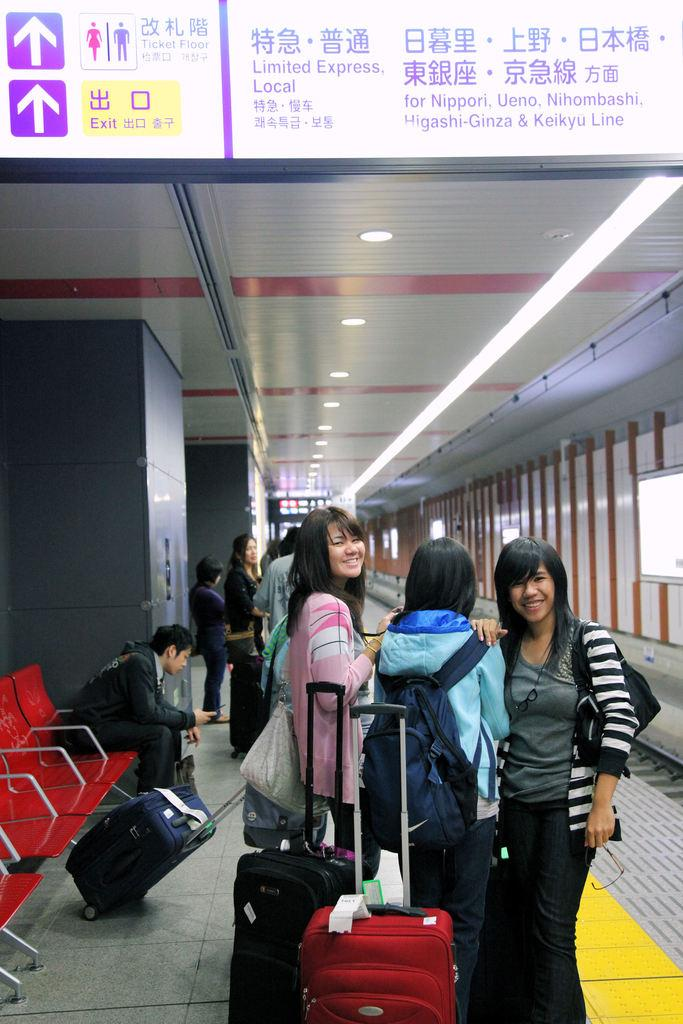What is the main subject of the image? The main subject of the image is a group of people. What are the people in the image doing? The people are standing and holding a suitcase. Can you describe the man in the image? The man is sitting on a chair and holding a mobile. What is visible on the roof in the image? There are lights on the roof. What type of humor can be seen in the image? There is no humor present in the image; it depicts a group of people standing and holding a suitcase, a man sitting on a chair holding a mobile, and lights on a roof. Can you tell me how many toothbrushes are visible in the image? There are no toothbrushes present in the image. 